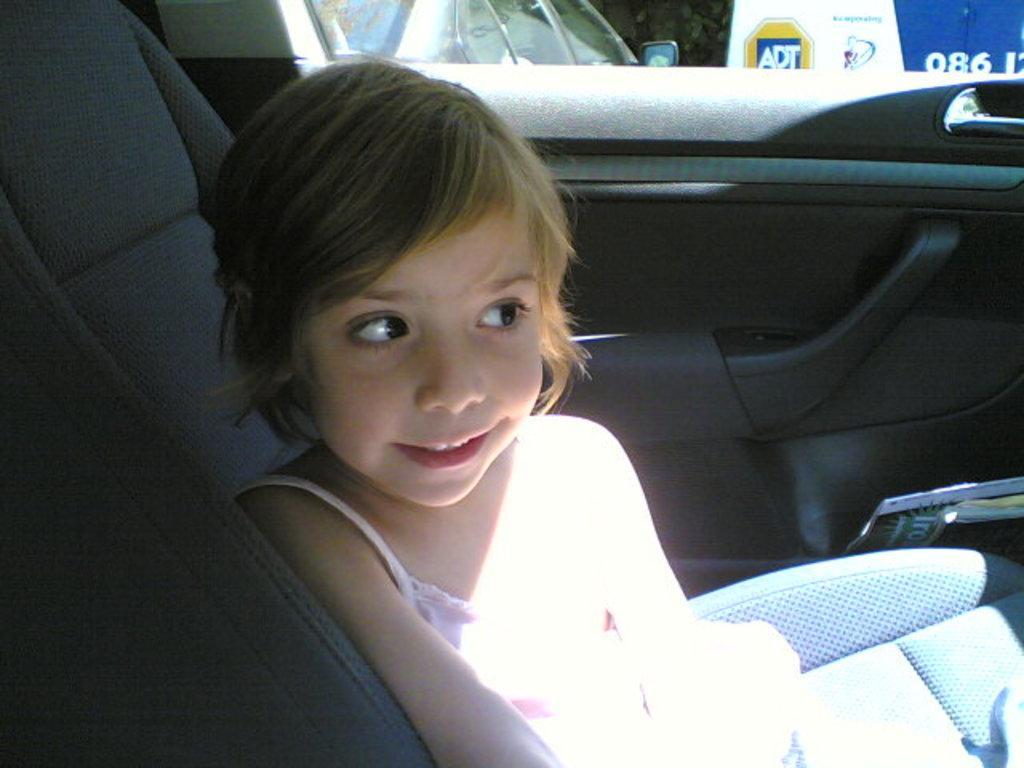In one or two sentences, can you explain what this image depicts? As we can see in the image there is a girl sitting in car. 